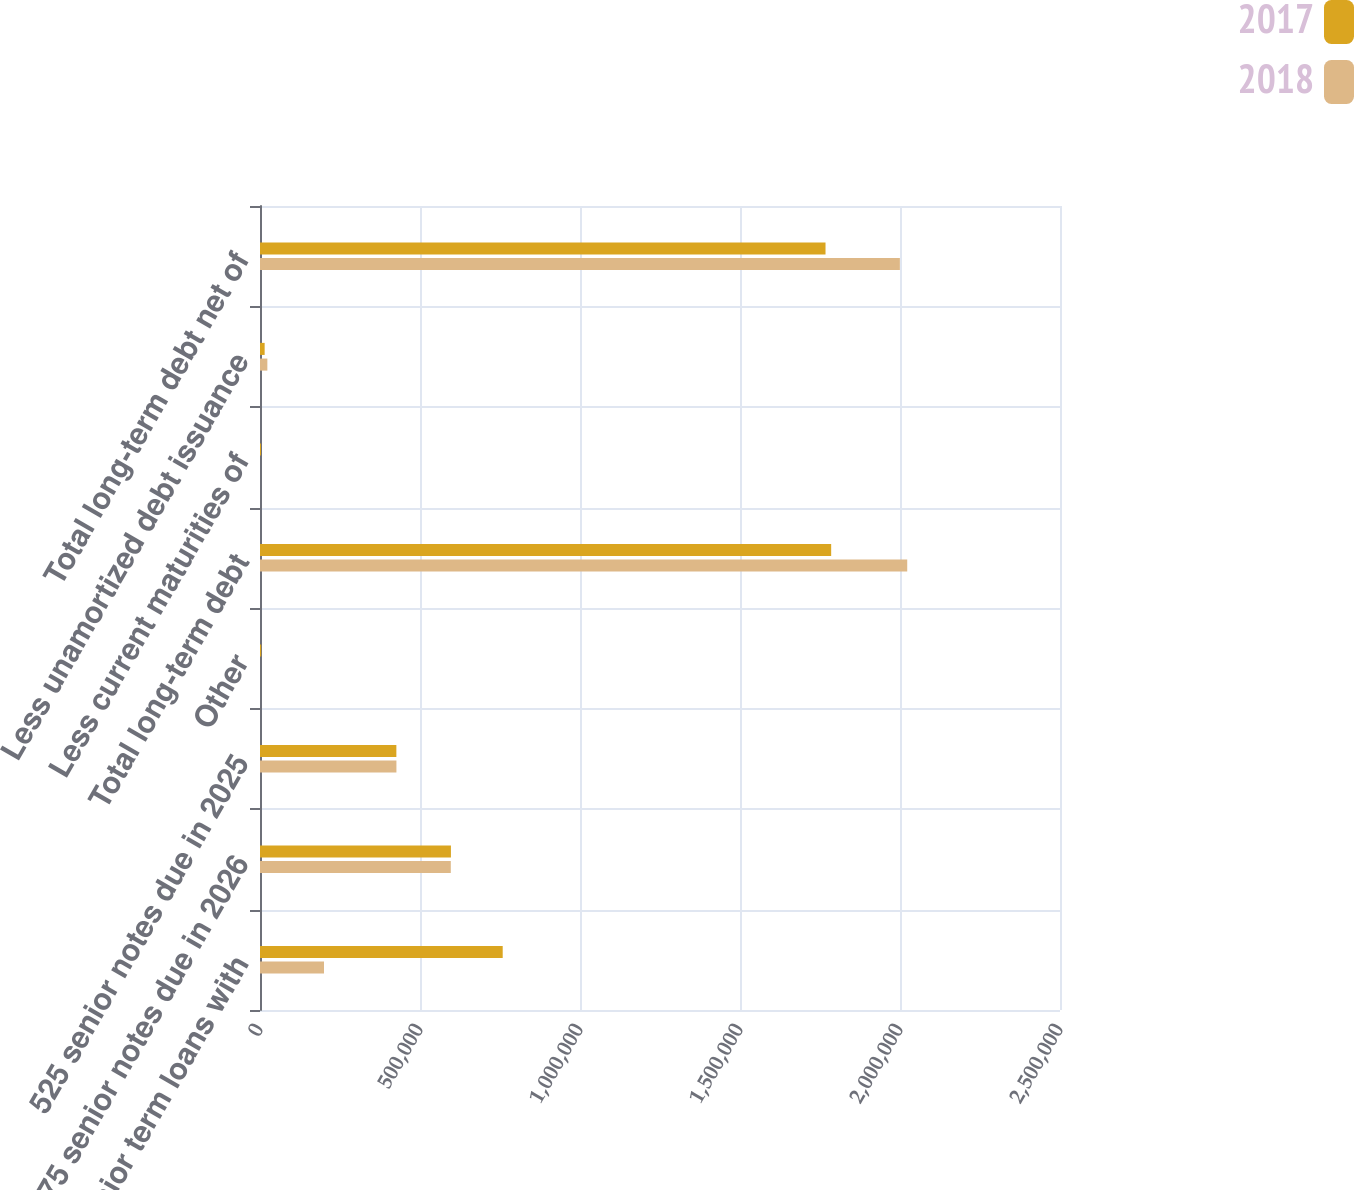<chart> <loc_0><loc_0><loc_500><loc_500><stacked_bar_chart><ecel><fcel>Senior term loans with<fcel>4875 senior notes due in 2026<fcel>525 senior notes due in 2025<fcel>Other<fcel>Total long-term debt<fcel>Less current maturities of<fcel>Less unamortized debt issuance<fcel>Total long-term debt net of<nl><fcel>2017<fcel>758452<fcel>596653<fcel>426134<fcel>3682<fcel>1.78492e+06<fcel>3146<fcel>14515<fcel>1.76726e+06<nl><fcel>2018<fcel>200000<fcel>596273<fcel>426317<fcel>8<fcel>2.0226e+06<fcel>8<fcel>22987<fcel>1.9996e+06<nl></chart> 